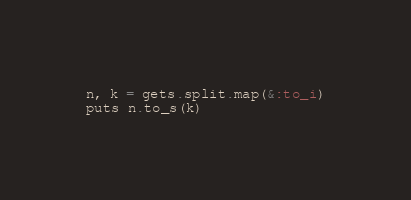Convert code to text. <code><loc_0><loc_0><loc_500><loc_500><_Ruby_>n, k = gets.split.map(&:to_i)
puts n.to_s(k)
</code> 